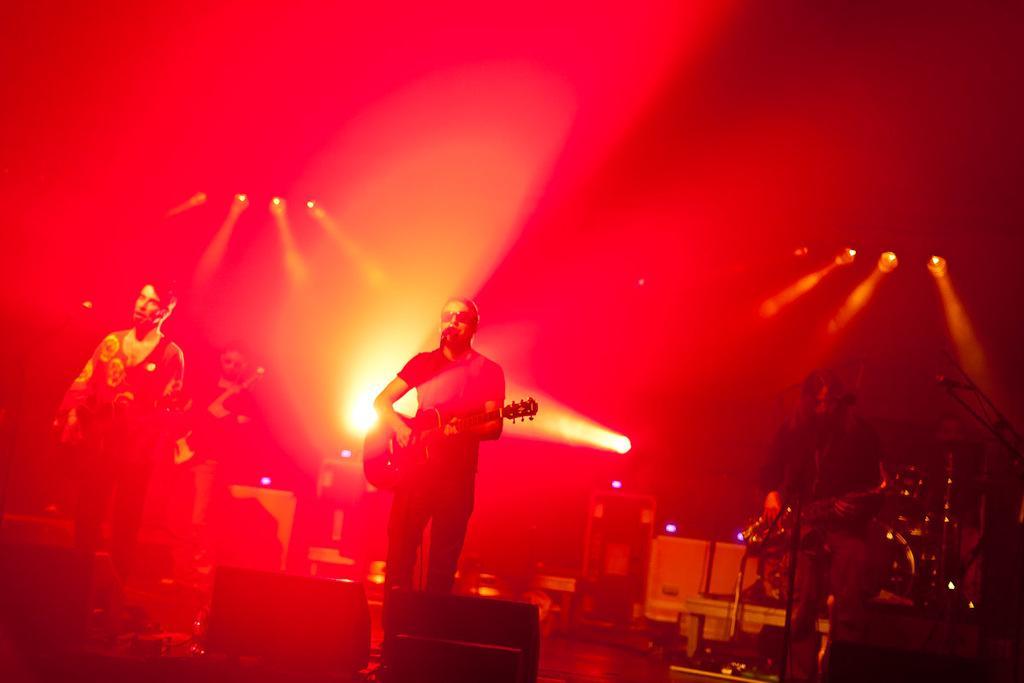In one or two sentences, can you explain what this image depicts? In the picture we can see three people are standing and they are playing some musical instruments and the background we can see the lights. 